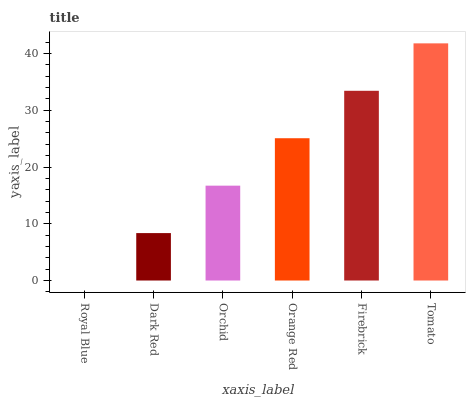Is Royal Blue the minimum?
Answer yes or no. Yes. Is Tomato the maximum?
Answer yes or no. Yes. Is Dark Red the minimum?
Answer yes or no. No. Is Dark Red the maximum?
Answer yes or no. No. Is Dark Red greater than Royal Blue?
Answer yes or no. Yes. Is Royal Blue less than Dark Red?
Answer yes or no. Yes. Is Royal Blue greater than Dark Red?
Answer yes or no. No. Is Dark Red less than Royal Blue?
Answer yes or no. No. Is Orange Red the high median?
Answer yes or no. Yes. Is Orchid the low median?
Answer yes or no. Yes. Is Tomato the high median?
Answer yes or no. No. Is Orange Red the low median?
Answer yes or no. No. 